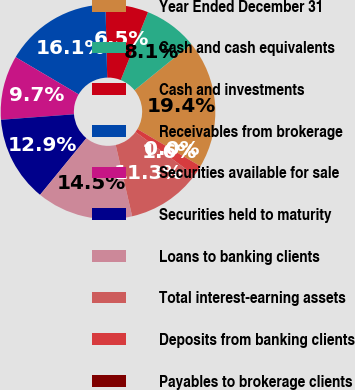Convert chart. <chart><loc_0><loc_0><loc_500><loc_500><pie_chart><fcel>Year Ended December 31<fcel>Cash and cash equivalents<fcel>Cash and investments<fcel>Receivables from brokerage<fcel>Securities available for sale<fcel>Securities held to maturity<fcel>Loans to banking clients<fcel>Total interest-earning assets<fcel>Deposits from banking clients<fcel>Payables to brokerage clients<nl><fcel>19.35%<fcel>8.06%<fcel>6.45%<fcel>16.13%<fcel>9.68%<fcel>12.9%<fcel>14.52%<fcel>11.29%<fcel>1.61%<fcel>0.0%<nl></chart> 